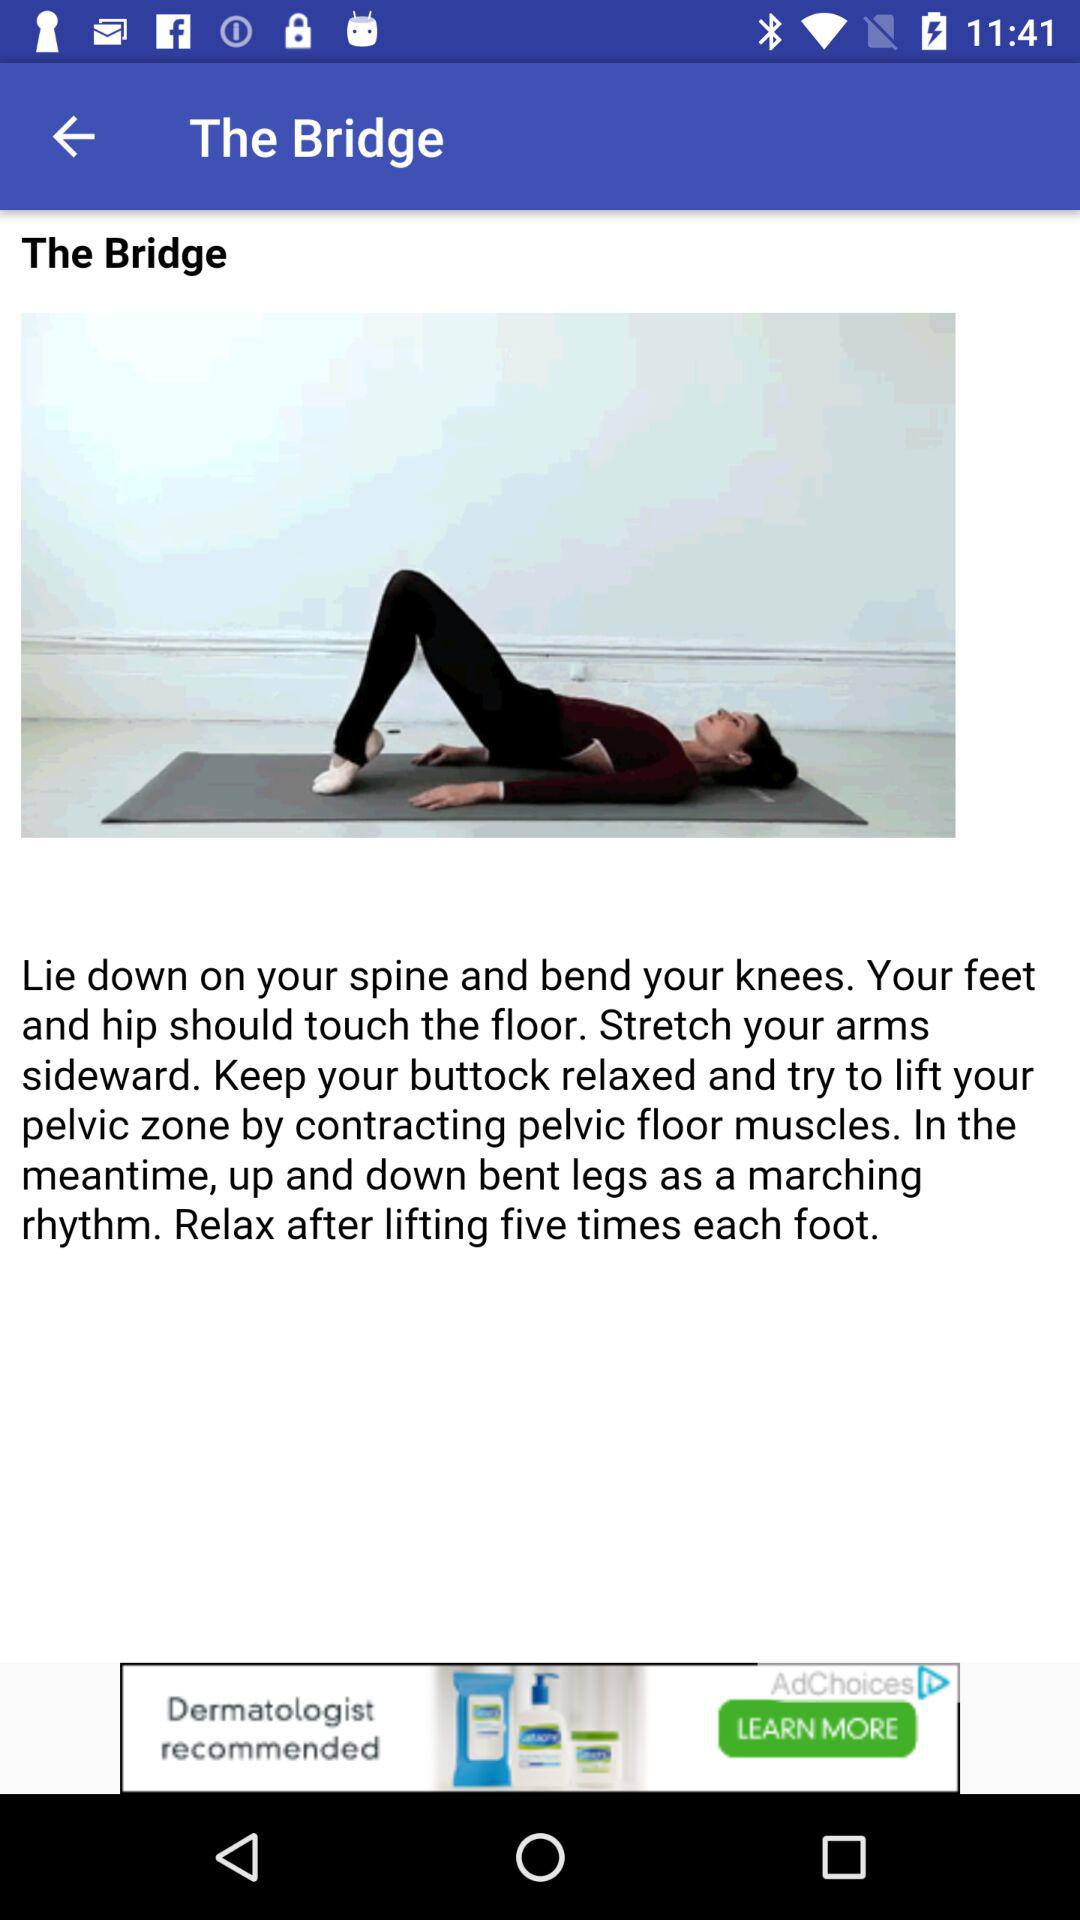How many times does each foot have to be lifted? Each foot has to be lifted five times. 